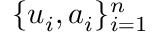Convert formula to latex. <formula><loc_0><loc_0><loc_500><loc_500>\{ u _ { i } , a _ { i } \} _ { i = 1 } ^ { n }</formula> 